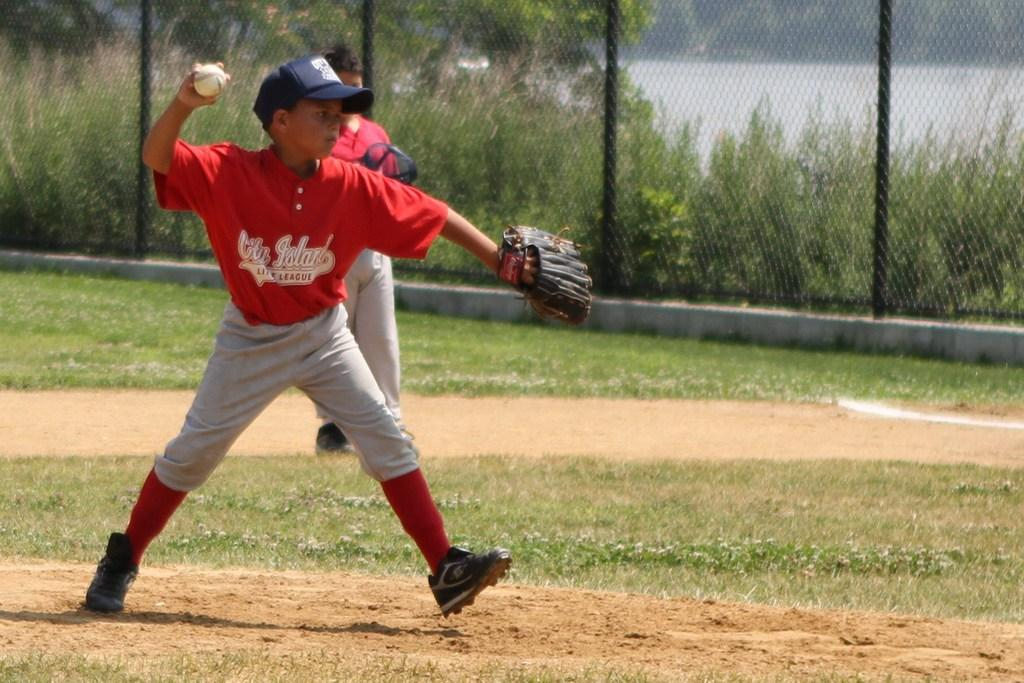<image>
Offer a succinct explanation of the picture presented. A City Island little league player is about to throw a baseball. 